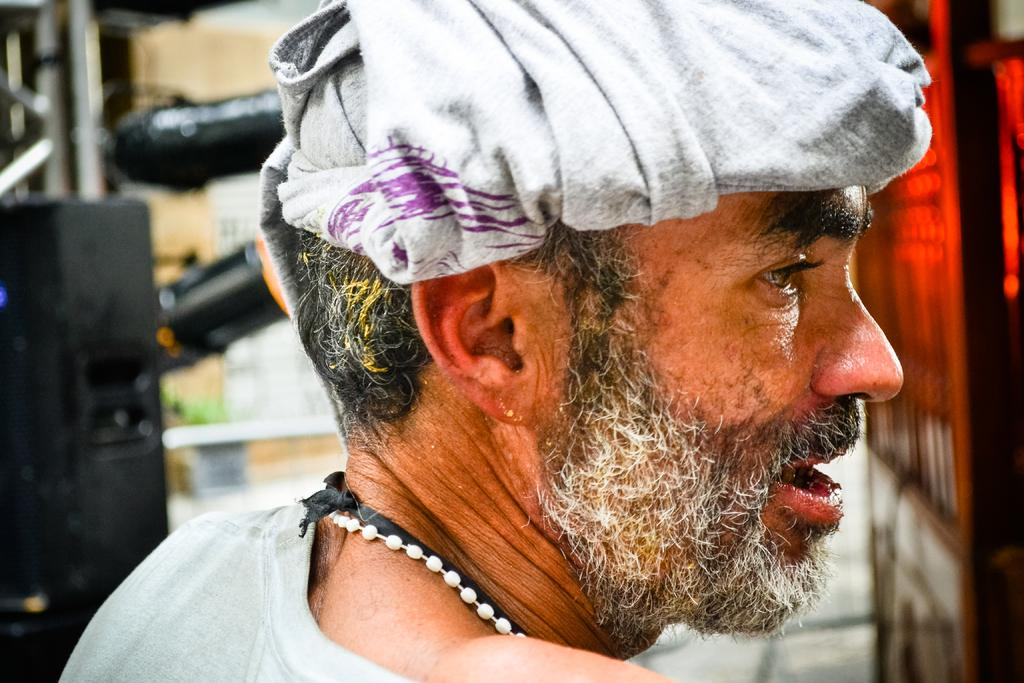What is the main subject in the foreground of the image? There is a person in the foreground of the image. Can you describe the background of the image? The background of the image is blurred. What type of throne is visible in the image? There is no throne present in the image. Does the person in the image express any regret? The image does not convey any emotions or expressions, so it cannot be determined if the person expresses regret. 